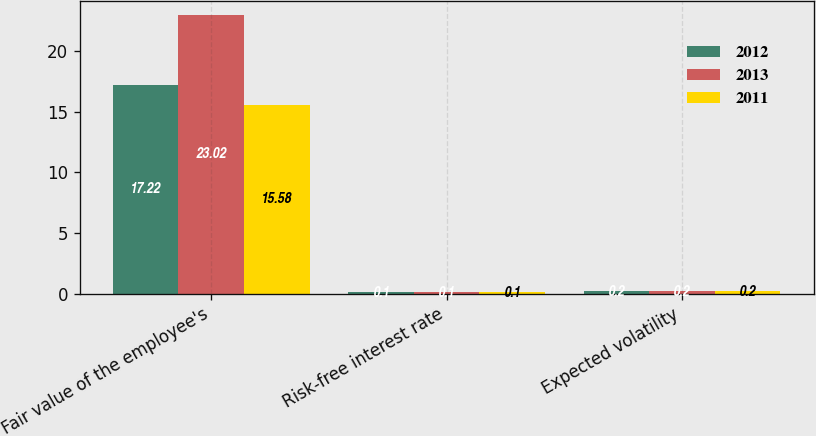Convert chart to OTSL. <chart><loc_0><loc_0><loc_500><loc_500><stacked_bar_chart><ecel><fcel>Fair value of the employee's<fcel>Risk-free interest rate<fcel>Expected volatility<nl><fcel>2012<fcel>17.22<fcel>0.1<fcel>0.2<nl><fcel>2013<fcel>23.02<fcel>0.1<fcel>0.2<nl><fcel>2011<fcel>15.58<fcel>0.1<fcel>0.2<nl></chart> 